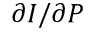<formula> <loc_0><loc_0><loc_500><loc_500>\partial I / \partial P</formula> 